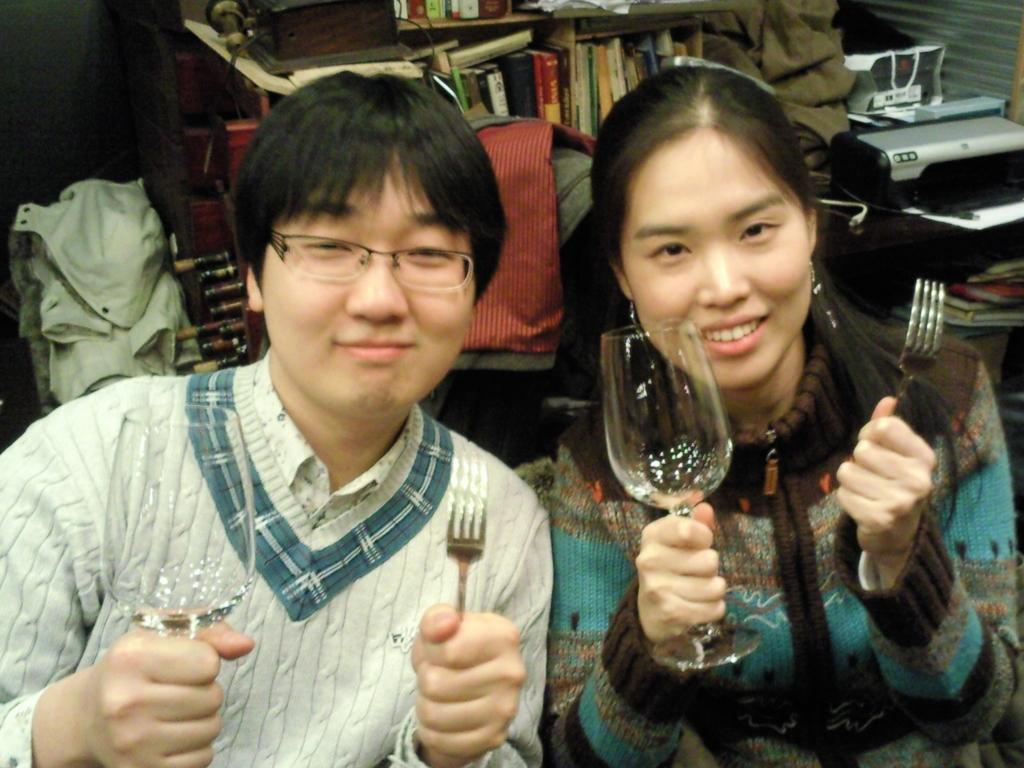How many people are in the image? There are two people in the image. What expressions do the people have? The people are smiling. What objects are the people holding? The people are holding glasses and forks. What can be seen in the background of the image? There is a shelf with books, a table, and a chair in the background of the image. What type of worm can be seen crawling on the table in the image? There is no worm present in the image; the table is clear of any such creatures. 